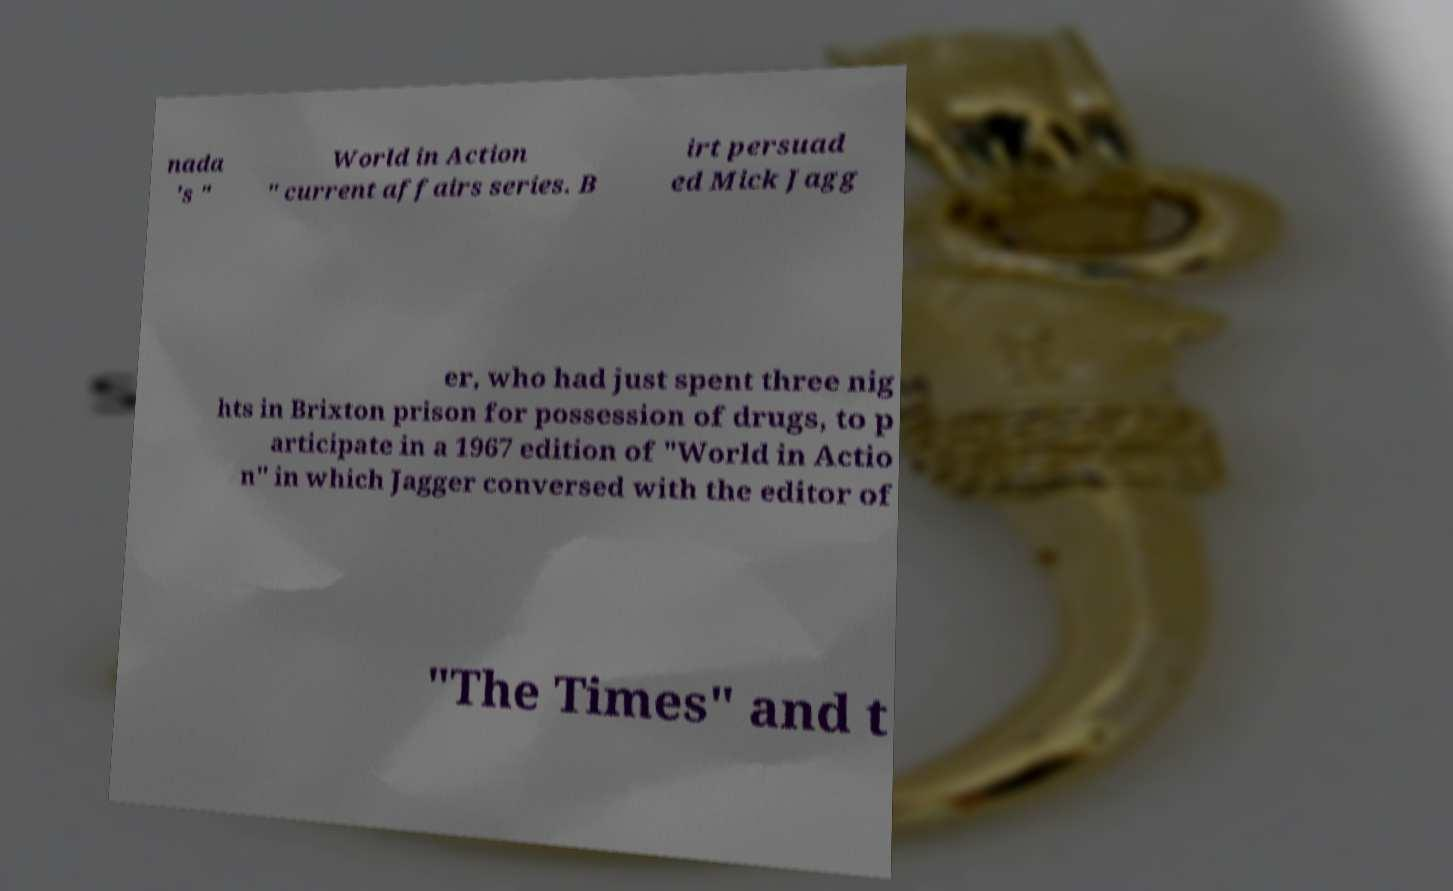Can you accurately transcribe the text from the provided image for me? nada 's " World in Action " current affairs series. B irt persuad ed Mick Jagg er, who had just spent three nig hts in Brixton prison for possession of drugs, to p articipate in a 1967 edition of "World in Actio n" in which Jagger conversed with the editor of "The Times" and t 